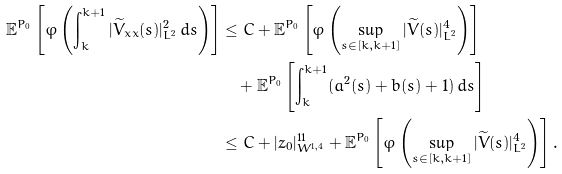<formula> <loc_0><loc_0><loc_500><loc_500>\mathbb { E } ^ { P _ { 0 } } \left [ \varphi \left ( \int _ { k } ^ { k + 1 } | \widetilde { V } _ { x x } ( s ) | _ { L ^ { 2 } } ^ { 2 } \, d s \right ) \right ] & \leq C + \mathbb { E } ^ { P _ { 0 } } \left [ \varphi \left ( \sup _ { s \in [ k , k + 1 ] } | \widetilde { V } ( s ) | _ { L ^ { 2 } } ^ { 4 } \right ) \right ] \\ & \quad + \mathbb { E } ^ { P _ { 0 } } \left [ \int _ { k } ^ { k + 1 } ( a ^ { 2 } ( s ) + b ( s ) + 1 ) \, d s \right ] \\ & \leq C + | z _ { 0 } | _ { W ^ { 1 , 4 } } ^ { 1 1 } + \mathbb { E } ^ { P _ { 0 } } \left [ \varphi \left ( \sup _ { s \in [ k , k + 1 ] } | \widetilde { V } ( s ) | _ { L ^ { 2 } } ^ { 4 } \right ) \right ] .</formula> 